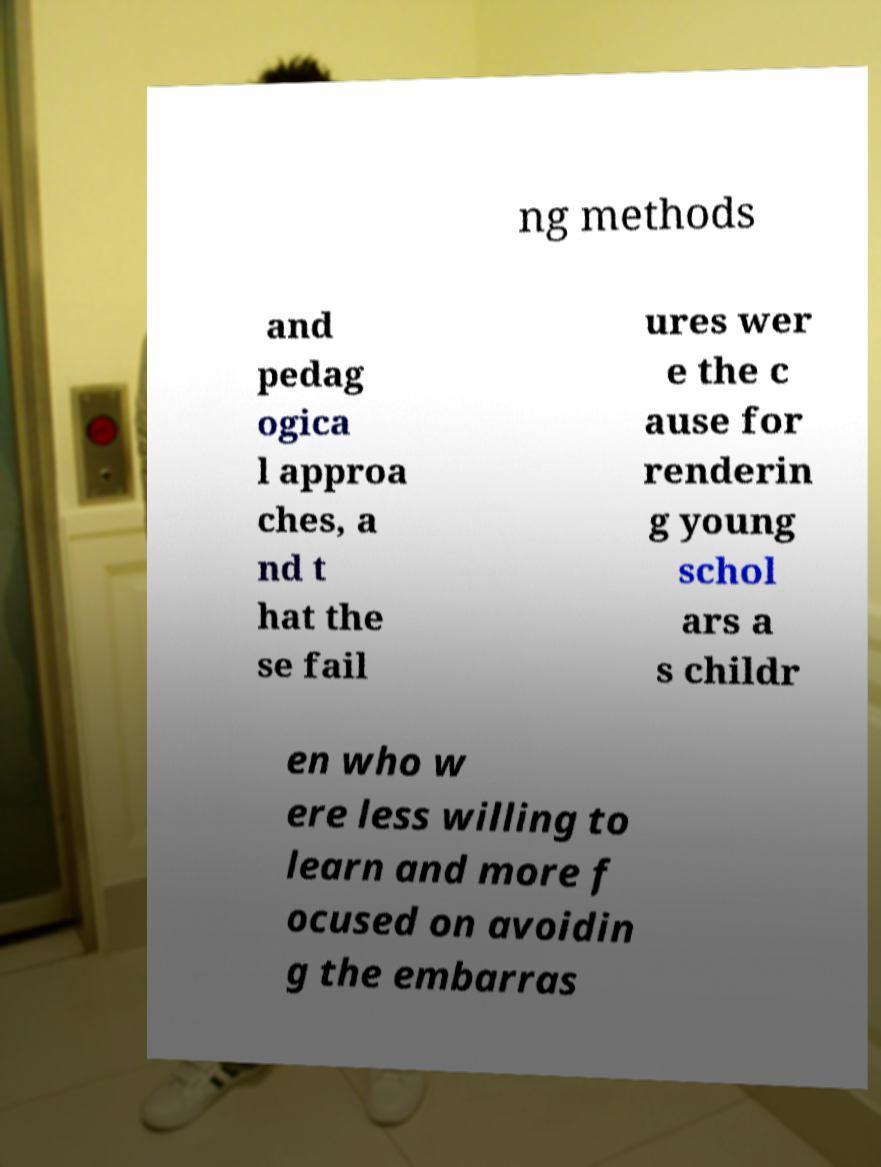Could you extract and type out the text from this image? ng methods and pedag ogica l approa ches, a nd t hat the se fail ures wer e the c ause for renderin g young schol ars a s childr en who w ere less willing to learn and more f ocused on avoidin g the embarras 